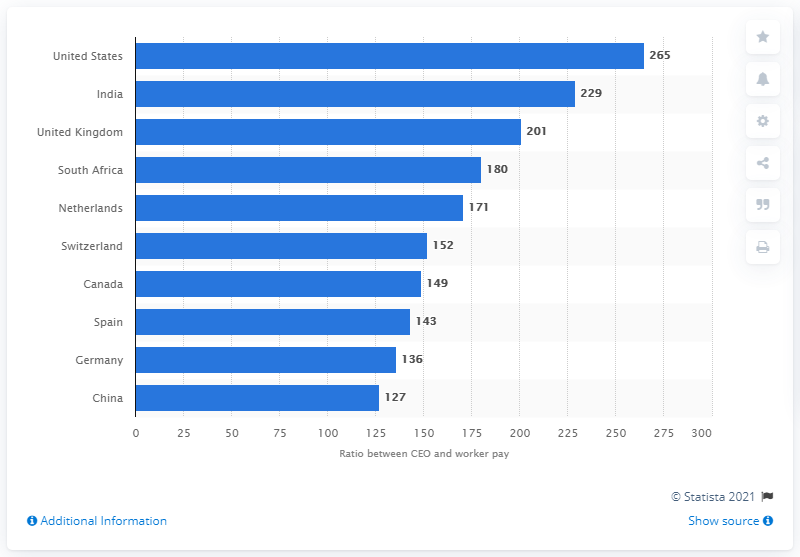Outline some significant characteristics in this image. The average CEO earned more than twice the amount earned by the average worker, with each dollar earned by the CEO translating to 265 dollars earned by the worker. 